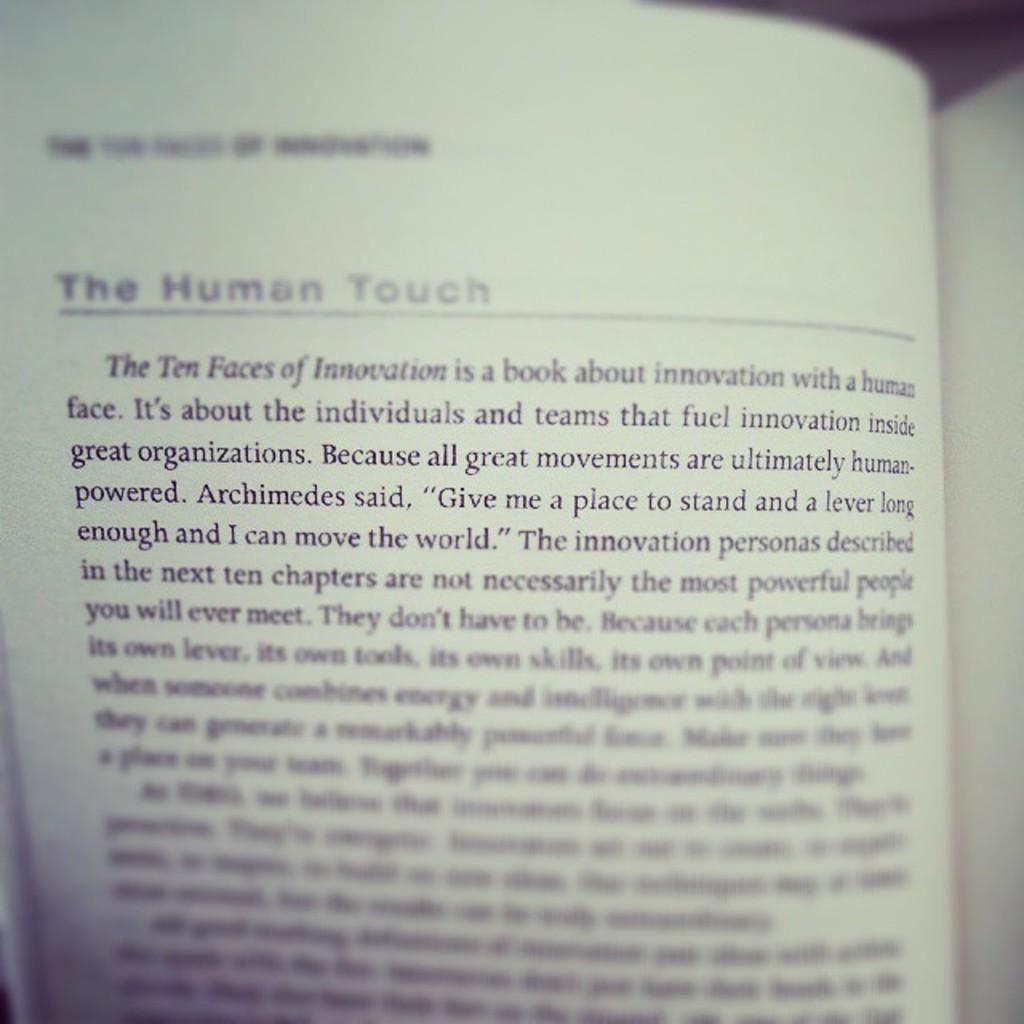<image>
Describe the image concisely. The Human Touch is the title of the page. 